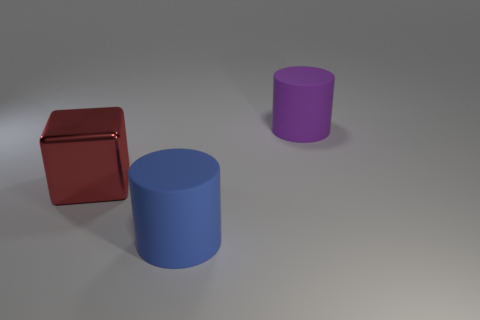What can you say about the texture of the surfaces? The objects in the image have a smooth and shiny texture, which is evident from the light reflections and clear highlights on their surfaces. 